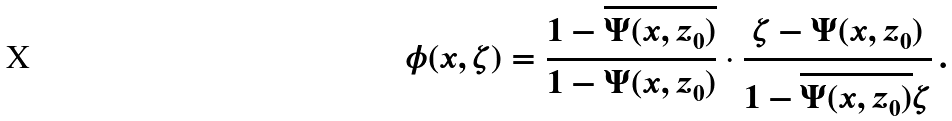<formula> <loc_0><loc_0><loc_500><loc_500>\phi ( x , \zeta ) = \frac { 1 - \overline { \Psi ( x , z _ { 0 } ) } } { 1 - \Psi ( x , z _ { 0 } ) } \cdot \frac { \zeta - \Psi ( x , z _ { 0 } ) } { 1 - \overline { \Psi ( x , z _ { 0 } ) } \zeta } \, .</formula> 